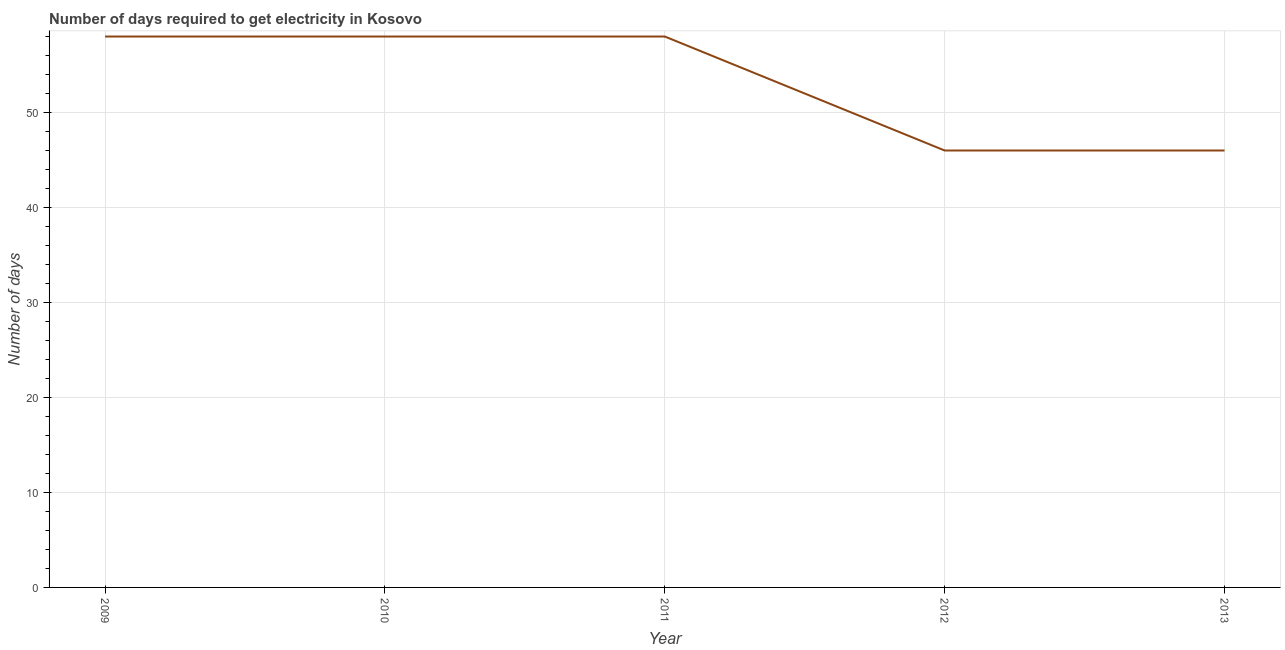What is the time to get electricity in 2009?
Ensure brevity in your answer.  58. Across all years, what is the maximum time to get electricity?
Keep it short and to the point. 58. Across all years, what is the minimum time to get electricity?
Make the answer very short. 46. In which year was the time to get electricity minimum?
Your answer should be very brief. 2012. What is the sum of the time to get electricity?
Offer a very short reply. 266. What is the difference between the time to get electricity in 2009 and 2011?
Make the answer very short. 0. What is the average time to get electricity per year?
Your response must be concise. 53.2. What is the ratio of the time to get electricity in 2010 to that in 2013?
Give a very brief answer. 1.26. What is the difference between the highest and the second highest time to get electricity?
Provide a short and direct response. 0. What is the difference between the highest and the lowest time to get electricity?
Give a very brief answer. 12. Does the time to get electricity monotonically increase over the years?
Make the answer very short. No. How many years are there in the graph?
Keep it short and to the point. 5. What is the difference between two consecutive major ticks on the Y-axis?
Keep it short and to the point. 10. Does the graph contain any zero values?
Offer a terse response. No. What is the title of the graph?
Provide a succinct answer. Number of days required to get electricity in Kosovo. What is the label or title of the X-axis?
Offer a terse response. Year. What is the label or title of the Y-axis?
Keep it short and to the point. Number of days. What is the Number of days of 2010?
Provide a short and direct response. 58. What is the Number of days in 2011?
Provide a short and direct response. 58. What is the difference between the Number of days in 2009 and 2011?
Your answer should be compact. 0. What is the difference between the Number of days in 2009 and 2012?
Give a very brief answer. 12. What is the difference between the Number of days in 2009 and 2013?
Ensure brevity in your answer.  12. What is the difference between the Number of days in 2010 and 2011?
Your response must be concise. 0. What is the difference between the Number of days in 2010 and 2012?
Your answer should be compact. 12. What is the ratio of the Number of days in 2009 to that in 2010?
Make the answer very short. 1. What is the ratio of the Number of days in 2009 to that in 2011?
Keep it short and to the point. 1. What is the ratio of the Number of days in 2009 to that in 2012?
Provide a succinct answer. 1.26. What is the ratio of the Number of days in 2009 to that in 2013?
Provide a short and direct response. 1.26. What is the ratio of the Number of days in 2010 to that in 2012?
Ensure brevity in your answer.  1.26. What is the ratio of the Number of days in 2010 to that in 2013?
Make the answer very short. 1.26. What is the ratio of the Number of days in 2011 to that in 2012?
Make the answer very short. 1.26. What is the ratio of the Number of days in 2011 to that in 2013?
Your answer should be very brief. 1.26. What is the ratio of the Number of days in 2012 to that in 2013?
Provide a succinct answer. 1. 